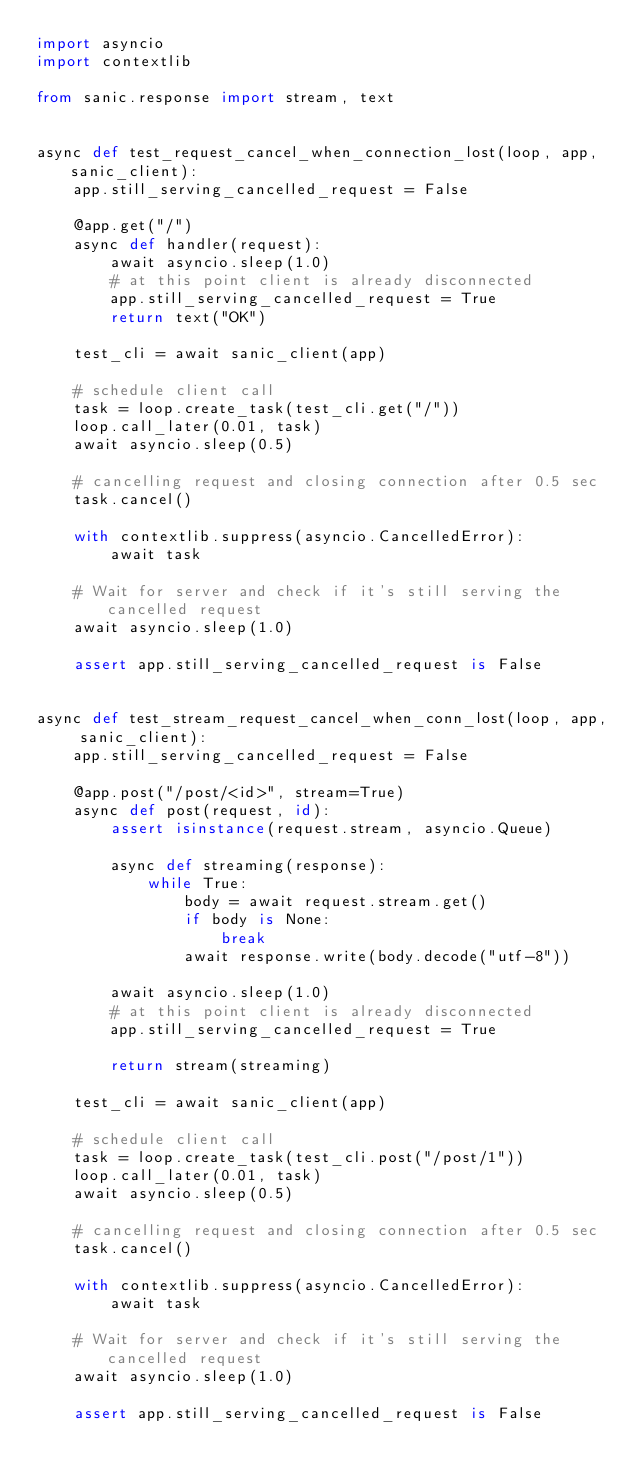<code> <loc_0><loc_0><loc_500><loc_500><_Python_>import asyncio
import contextlib

from sanic.response import stream, text


async def test_request_cancel_when_connection_lost(loop, app, sanic_client):
    app.still_serving_cancelled_request = False

    @app.get("/")
    async def handler(request):
        await asyncio.sleep(1.0)
        # at this point client is already disconnected
        app.still_serving_cancelled_request = True
        return text("OK")

    test_cli = await sanic_client(app)

    # schedule client call
    task = loop.create_task(test_cli.get("/"))
    loop.call_later(0.01, task)
    await asyncio.sleep(0.5)

    # cancelling request and closing connection after 0.5 sec
    task.cancel()

    with contextlib.suppress(asyncio.CancelledError):
        await task

    # Wait for server and check if it's still serving the cancelled request
    await asyncio.sleep(1.0)

    assert app.still_serving_cancelled_request is False


async def test_stream_request_cancel_when_conn_lost(loop, app, sanic_client):
    app.still_serving_cancelled_request = False

    @app.post("/post/<id>", stream=True)
    async def post(request, id):
        assert isinstance(request.stream, asyncio.Queue)

        async def streaming(response):
            while True:
                body = await request.stream.get()
                if body is None:
                    break
                await response.write(body.decode("utf-8"))

        await asyncio.sleep(1.0)
        # at this point client is already disconnected
        app.still_serving_cancelled_request = True

        return stream(streaming)

    test_cli = await sanic_client(app)

    # schedule client call
    task = loop.create_task(test_cli.post("/post/1"))
    loop.call_later(0.01, task)
    await asyncio.sleep(0.5)

    # cancelling request and closing connection after 0.5 sec
    task.cancel()

    with contextlib.suppress(asyncio.CancelledError):
        await task

    # Wait for server and check if it's still serving the cancelled request
    await asyncio.sleep(1.0)

    assert app.still_serving_cancelled_request is False
</code> 